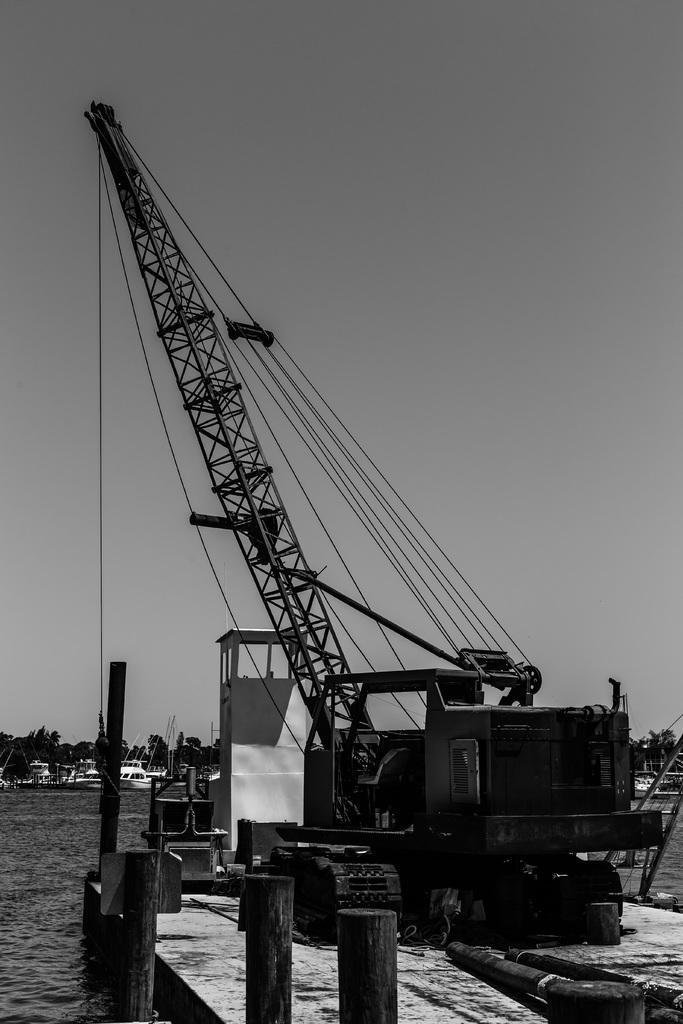Could you give a brief overview of what you see in this image? In this picture I can observe mobile crane. In the bottom of the picture there are wooden poles. I can observe a river in front of the crane. In the background there are trees and sky. 